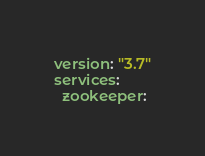<code> <loc_0><loc_0><loc_500><loc_500><_YAML_>version: "3.7"
services:
  zookeeper:</code> 